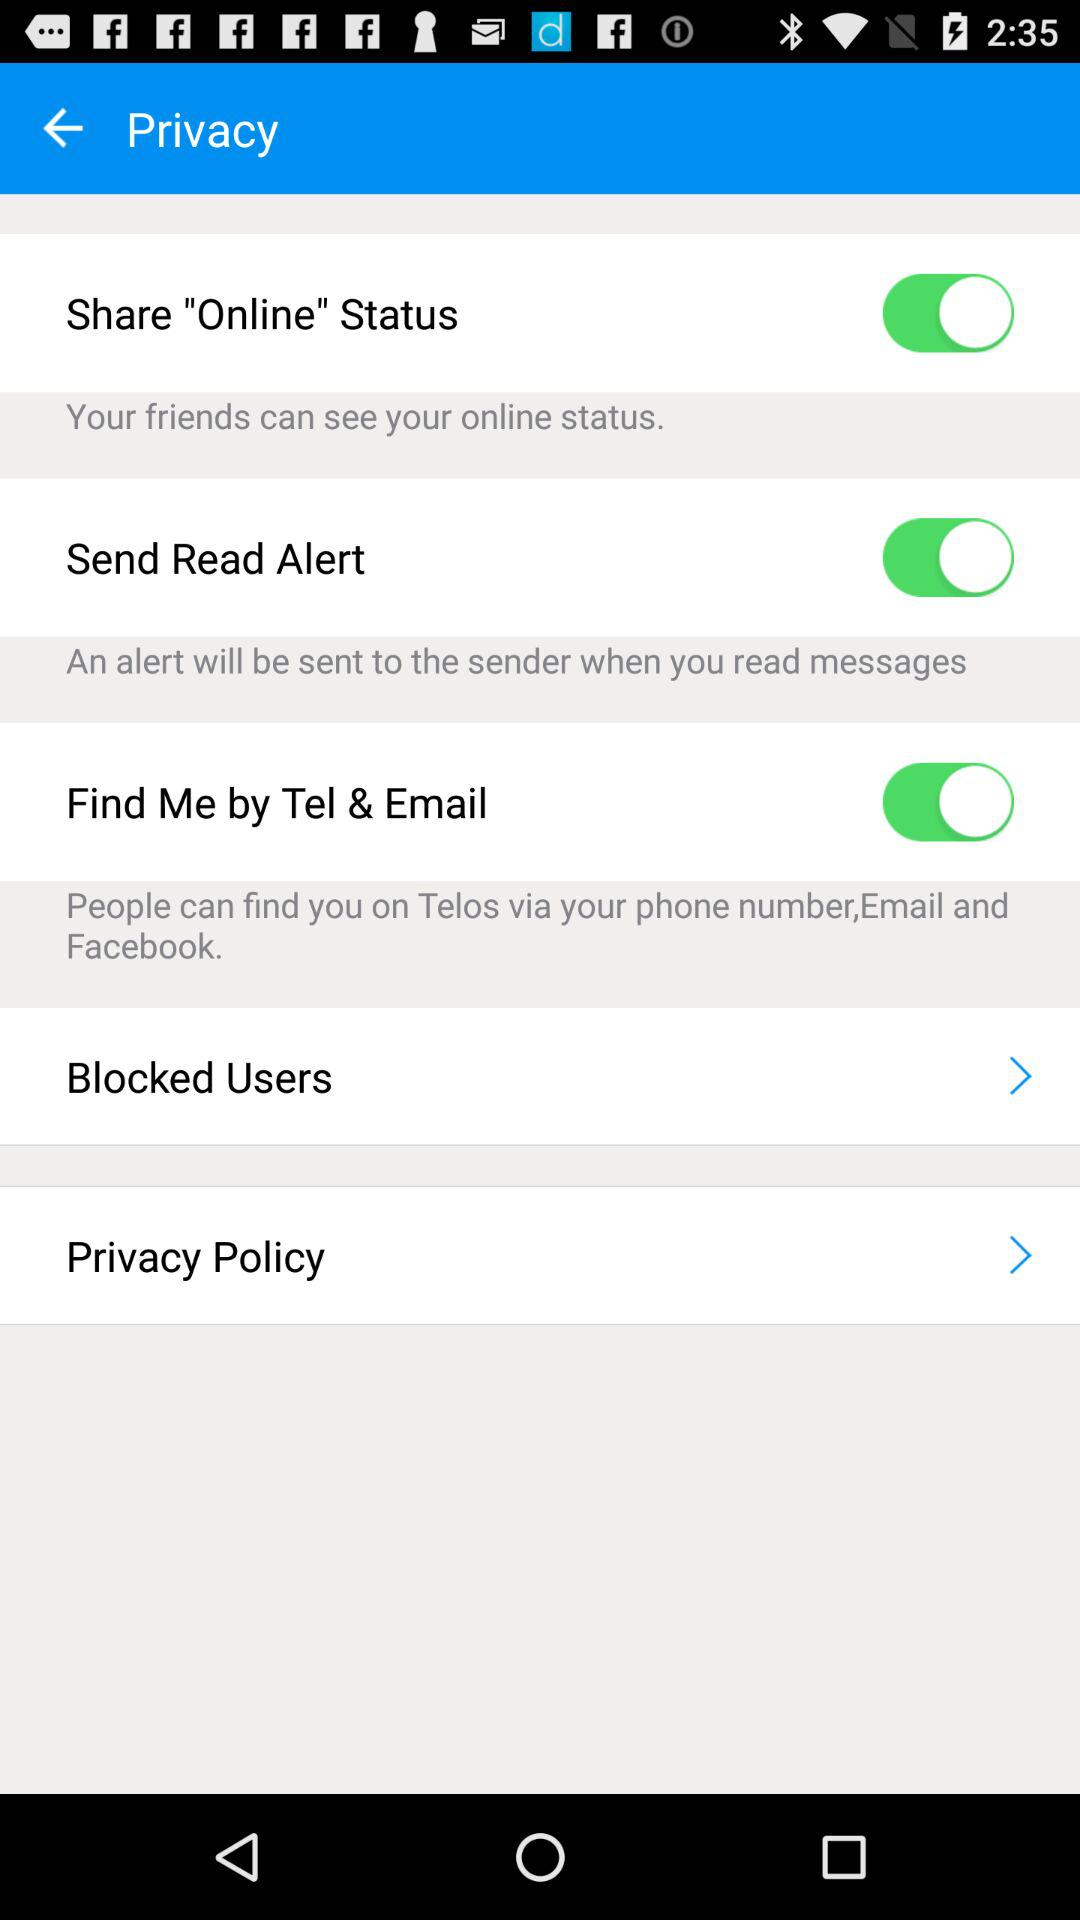Can I control who sees when I'm online? The image shows that there is a setting titled 'Share "Online" Status', which currently is toggled on. The description below it indicates that your friends can see your online status when this option is enabled. You can control this visibility by toggling this setting off if you prefer more privacy. 